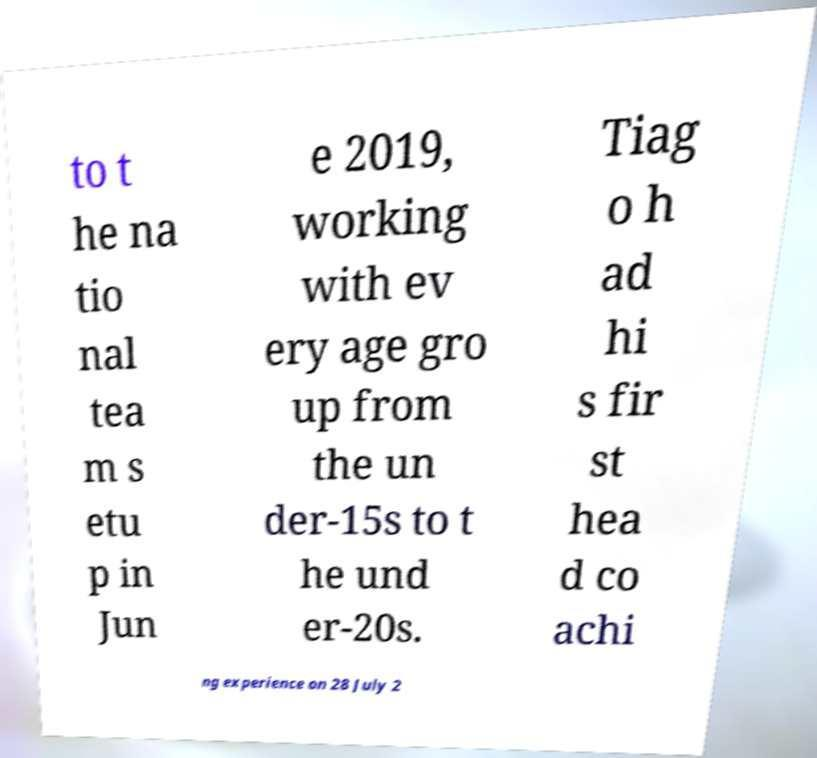Please read and relay the text visible in this image. What does it say? to t he na tio nal tea m s etu p in Jun e 2019, working with ev ery age gro up from the un der-15s to t he und er-20s. Tiag o h ad hi s fir st hea d co achi ng experience on 28 July 2 